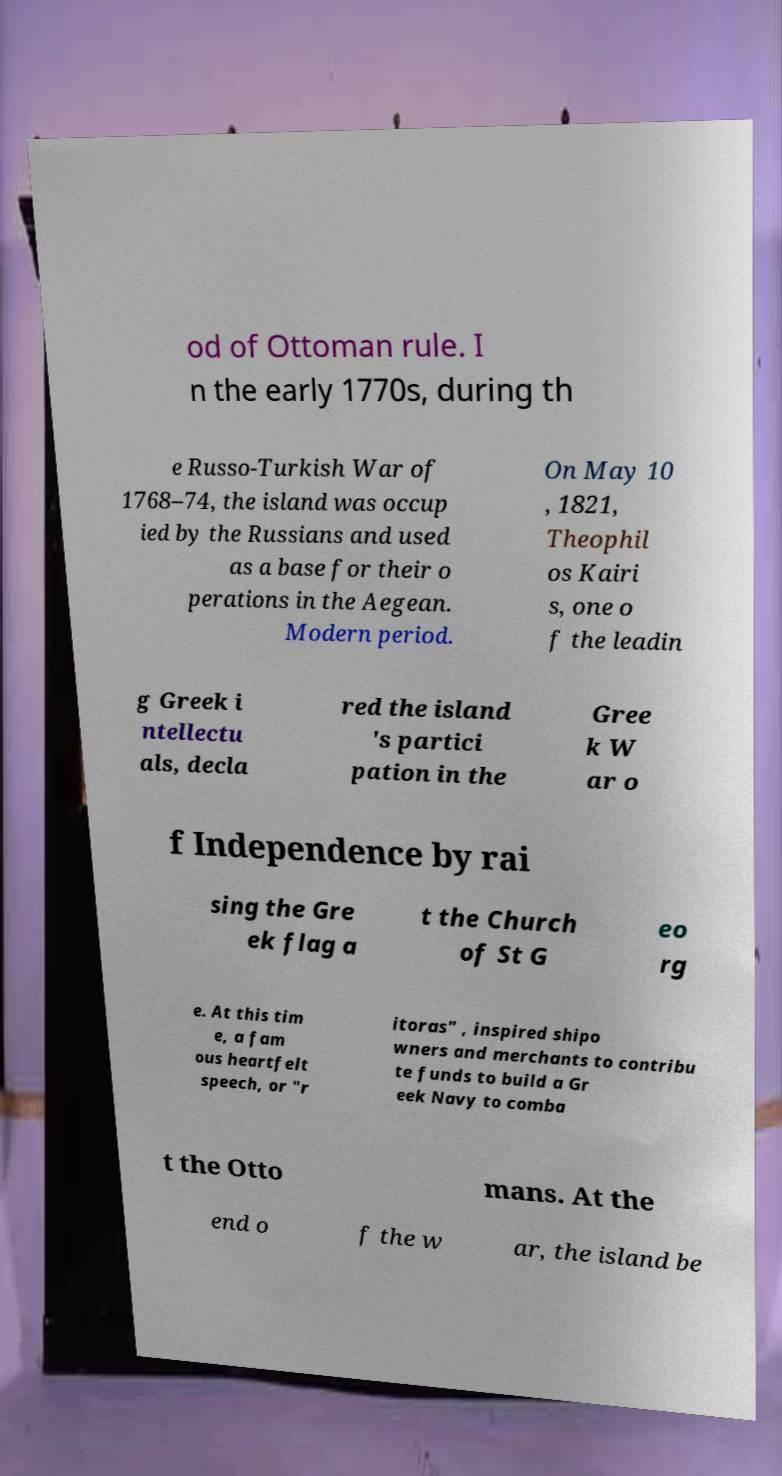For documentation purposes, I need the text within this image transcribed. Could you provide that? od of Ottoman rule. I n the early 1770s, during th e Russo-Turkish War of 1768–74, the island was occup ied by the Russians and used as a base for their o perations in the Aegean. Modern period. On May 10 , 1821, Theophil os Kairi s, one o f the leadin g Greek i ntellectu als, decla red the island 's partici pation in the Gree k W ar o f Independence by rai sing the Gre ek flag a t the Church of St G eo rg e. At this tim e, a fam ous heartfelt speech, or "r itoras" , inspired shipo wners and merchants to contribu te funds to build a Gr eek Navy to comba t the Otto mans. At the end o f the w ar, the island be 